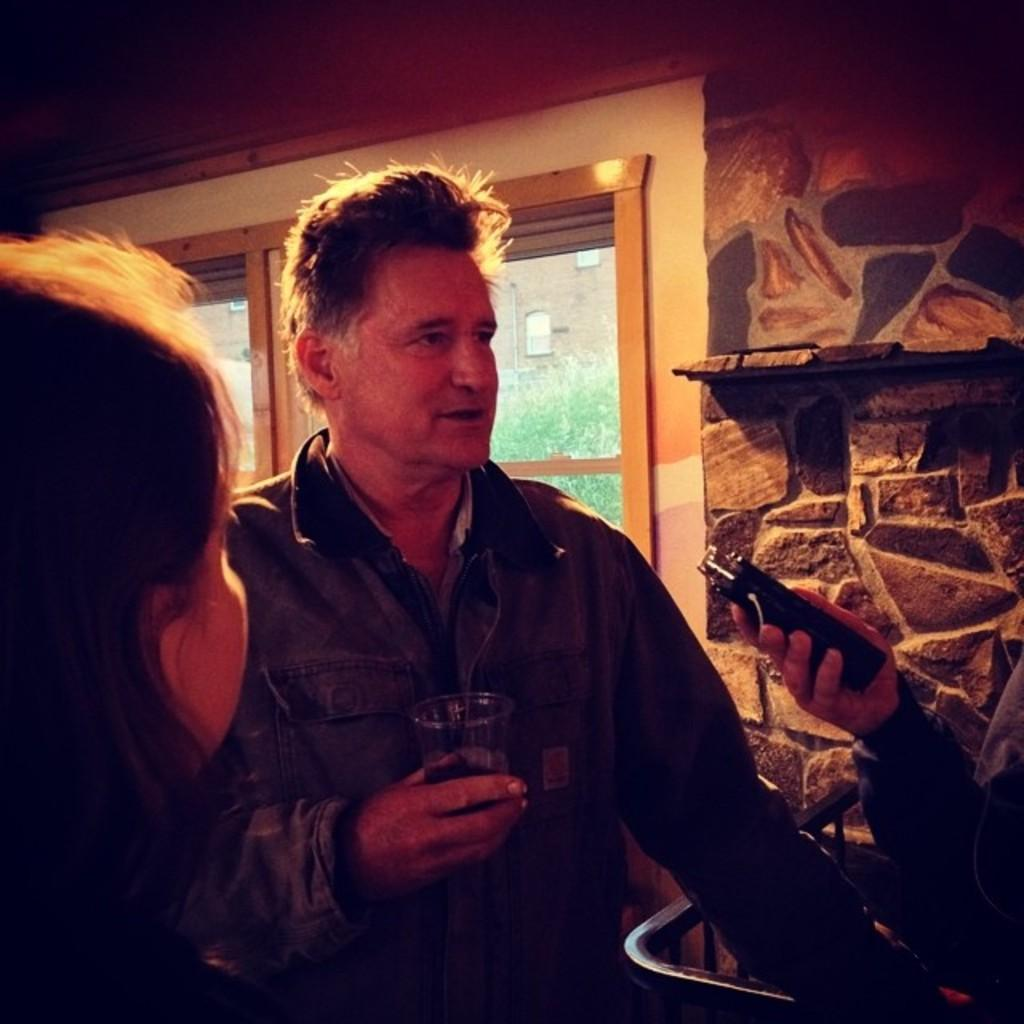How many people are in the image? There are two persons in the image. What can be seen through the window in the image? The information provided does not specify what can be seen through the window. What is visible at the top of the image? There is a wall visible at the top of the image. What type of flame can be seen in the image? There is no flame present in the image. What is the attention of the persons in the image? The information provided does not specify the attention or focus of the persons in the image. 